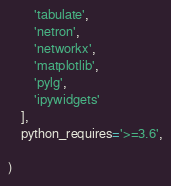<code> <loc_0><loc_0><loc_500><loc_500><_Python_>        'tabulate',
        'netron',
        'networkx',
        'matplotlib',
        'pylg',
        'ipywidgets'
    ],
    python_requires='>=3.6',

)





</code> 